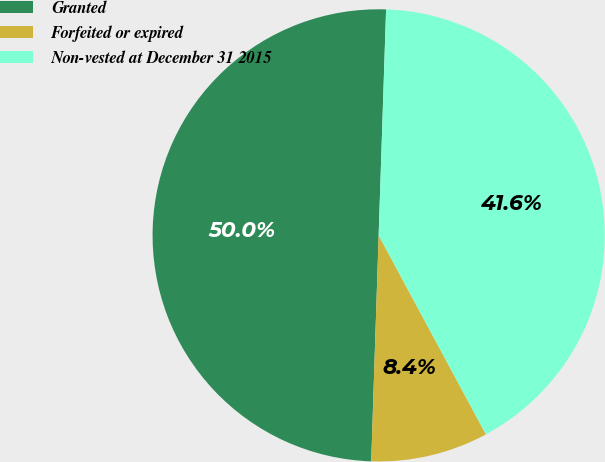Convert chart. <chart><loc_0><loc_0><loc_500><loc_500><pie_chart><fcel>Granted<fcel>Forfeited or expired<fcel>Non-vested at December 31 2015<nl><fcel>50.0%<fcel>8.39%<fcel>41.61%<nl></chart> 